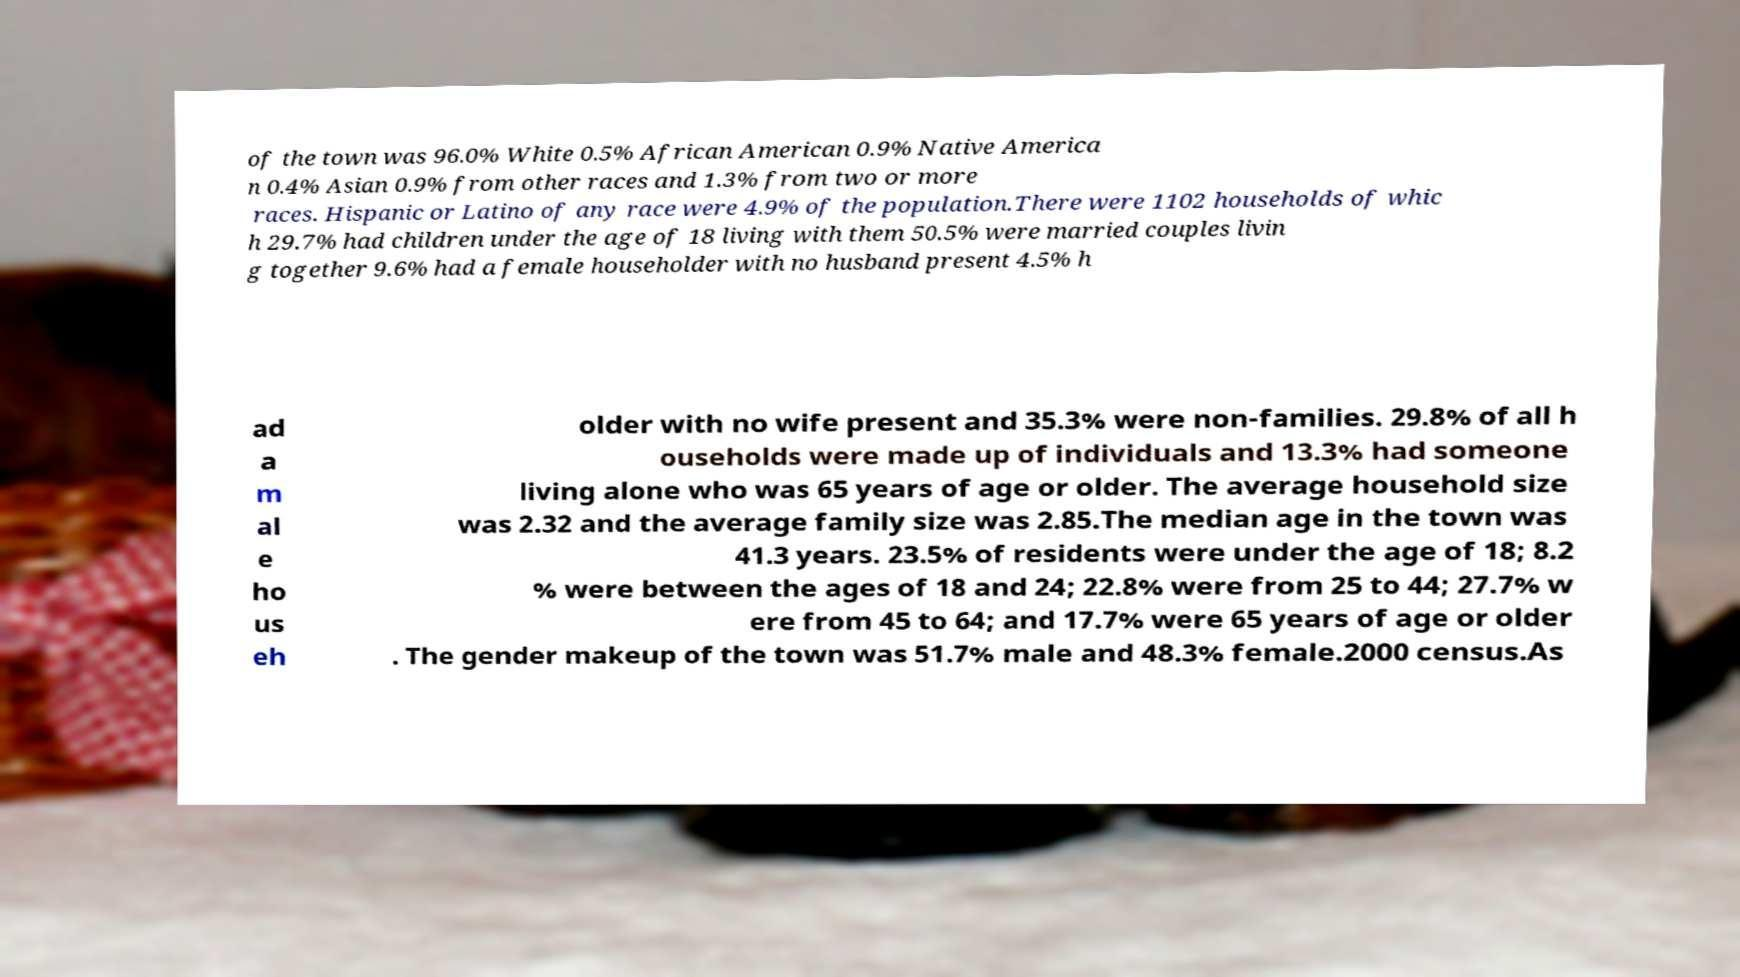Can you accurately transcribe the text from the provided image for me? of the town was 96.0% White 0.5% African American 0.9% Native America n 0.4% Asian 0.9% from other races and 1.3% from two or more races. Hispanic or Latino of any race were 4.9% of the population.There were 1102 households of whic h 29.7% had children under the age of 18 living with them 50.5% were married couples livin g together 9.6% had a female householder with no husband present 4.5% h ad a m al e ho us eh older with no wife present and 35.3% were non-families. 29.8% of all h ouseholds were made up of individuals and 13.3% had someone living alone who was 65 years of age or older. The average household size was 2.32 and the average family size was 2.85.The median age in the town was 41.3 years. 23.5% of residents were under the age of 18; 8.2 % were between the ages of 18 and 24; 22.8% were from 25 to 44; 27.7% w ere from 45 to 64; and 17.7% were 65 years of age or older . The gender makeup of the town was 51.7% male and 48.3% female.2000 census.As 